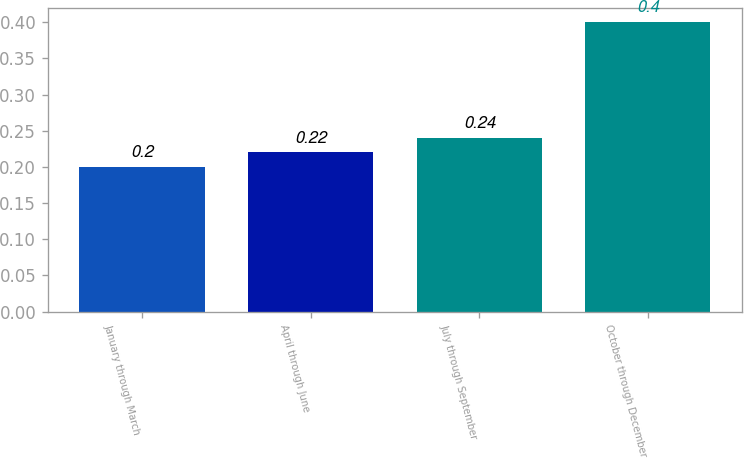Convert chart to OTSL. <chart><loc_0><loc_0><loc_500><loc_500><bar_chart><fcel>January through March<fcel>April through June<fcel>July through September<fcel>October through December<nl><fcel>0.2<fcel>0.22<fcel>0.24<fcel>0.4<nl></chart> 